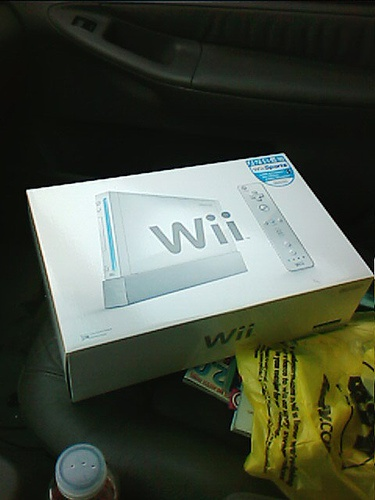Describe the objects in this image and their specific colors. I can see bottle in black, gray, and teal tones, remote in black, lightblue, darkgray, and lightgray tones, book in black and darkgreen tones, book in black, olive, maroon, and darkgreen tones, and book in black, olive, green, and darkgreen tones in this image. 